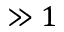Convert formula to latex. <formula><loc_0><loc_0><loc_500><loc_500>\gg 1</formula> 